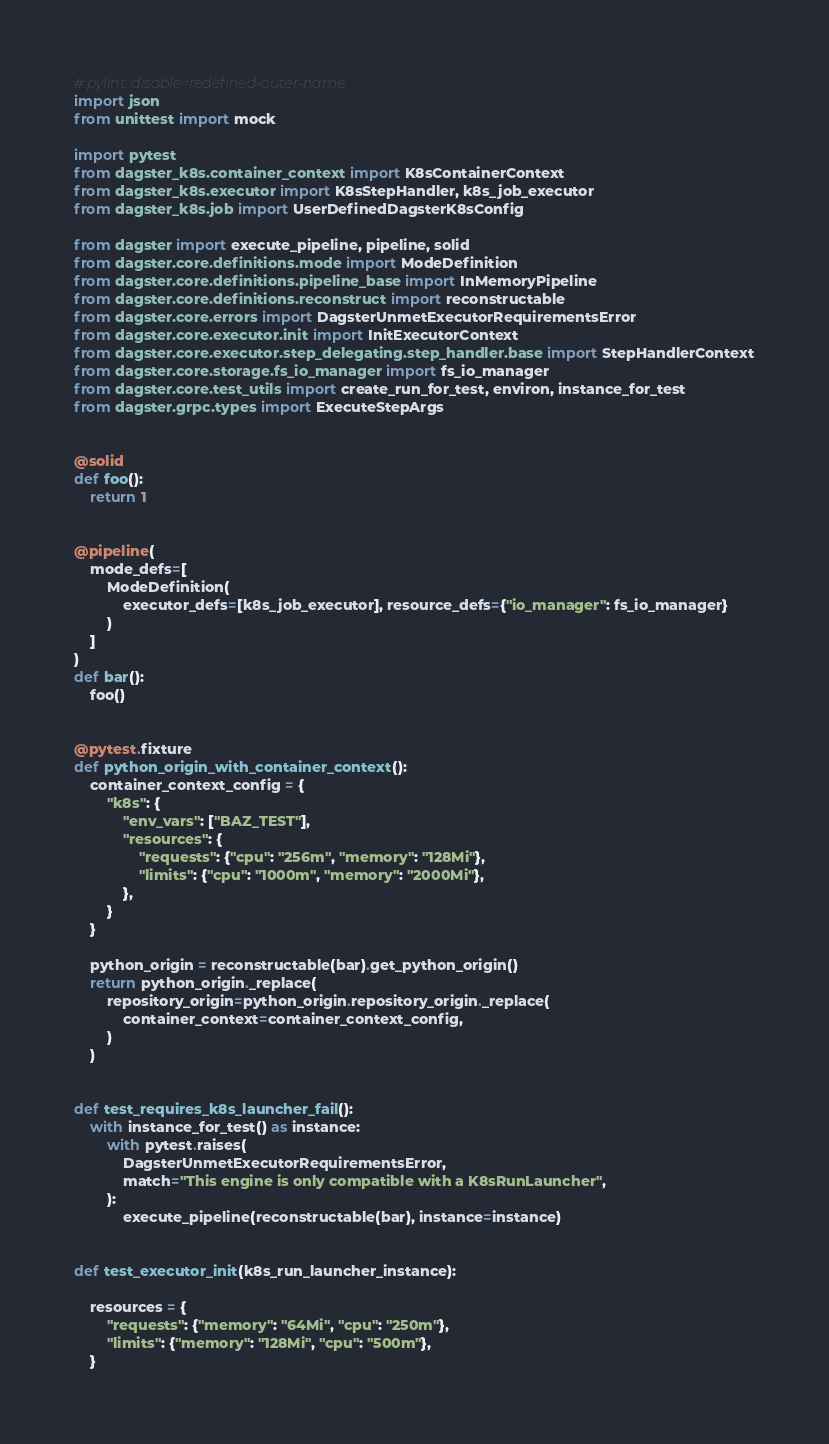<code> <loc_0><loc_0><loc_500><loc_500><_Python_># pylint: disable=redefined-outer-name
import json
from unittest import mock

import pytest
from dagster_k8s.container_context import K8sContainerContext
from dagster_k8s.executor import K8sStepHandler, k8s_job_executor
from dagster_k8s.job import UserDefinedDagsterK8sConfig

from dagster import execute_pipeline, pipeline, solid
from dagster.core.definitions.mode import ModeDefinition
from dagster.core.definitions.pipeline_base import InMemoryPipeline
from dagster.core.definitions.reconstruct import reconstructable
from dagster.core.errors import DagsterUnmetExecutorRequirementsError
from dagster.core.executor.init import InitExecutorContext
from dagster.core.executor.step_delegating.step_handler.base import StepHandlerContext
from dagster.core.storage.fs_io_manager import fs_io_manager
from dagster.core.test_utils import create_run_for_test, environ, instance_for_test
from dagster.grpc.types import ExecuteStepArgs


@solid
def foo():
    return 1


@pipeline(
    mode_defs=[
        ModeDefinition(
            executor_defs=[k8s_job_executor], resource_defs={"io_manager": fs_io_manager}
        )
    ]
)
def bar():
    foo()


@pytest.fixture
def python_origin_with_container_context():
    container_context_config = {
        "k8s": {
            "env_vars": ["BAZ_TEST"],
            "resources": {
                "requests": {"cpu": "256m", "memory": "128Mi"},
                "limits": {"cpu": "1000m", "memory": "2000Mi"},
            },
        }
    }

    python_origin = reconstructable(bar).get_python_origin()
    return python_origin._replace(
        repository_origin=python_origin.repository_origin._replace(
            container_context=container_context_config,
        )
    )


def test_requires_k8s_launcher_fail():
    with instance_for_test() as instance:
        with pytest.raises(
            DagsterUnmetExecutorRequirementsError,
            match="This engine is only compatible with a K8sRunLauncher",
        ):
            execute_pipeline(reconstructable(bar), instance=instance)


def test_executor_init(k8s_run_launcher_instance):

    resources = {
        "requests": {"memory": "64Mi", "cpu": "250m"},
        "limits": {"memory": "128Mi", "cpu": "500m"},
    }
</code> 